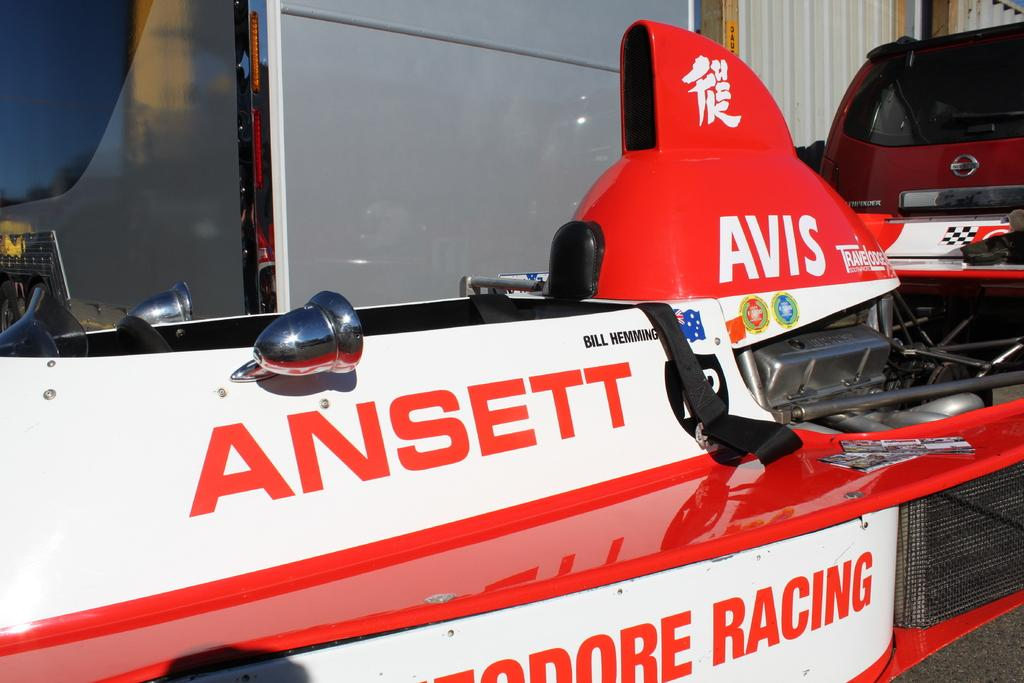What is the main object in the image? There is a vehicle-like object in the image. Can you describe any text or writing on the vehicle-like object? Something is written on the vehicle-like object. What type of material can be seen in the top right side of the image? There are tin walls visible in the top right side of the image. What type of guitar is being played in the image? There is no guitar present in the image. What is the purpose of the locket in the image? There is no locket present in the image. 